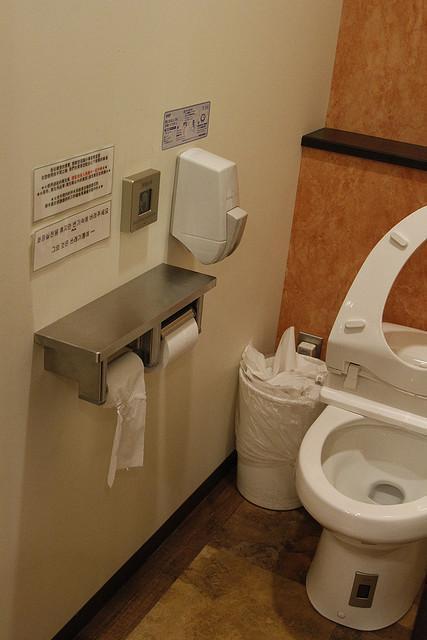How many rolls of toilet paper are there?
Give a very brief answer. 2. How many people are wearing red shirt?
Give a very brief answer. 0. 